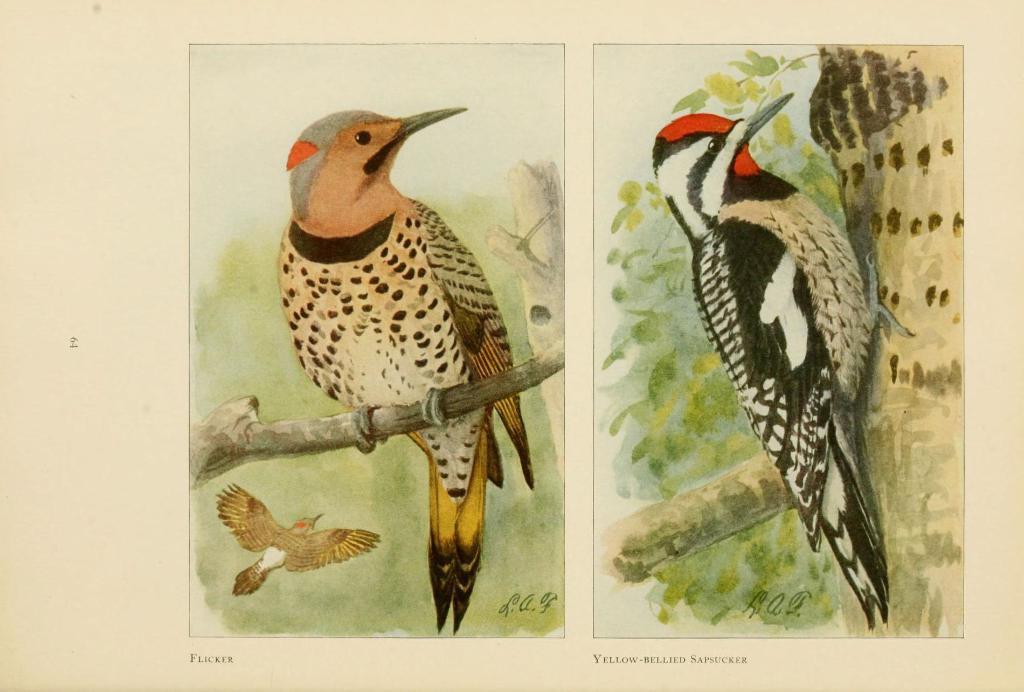In one or two sentences, can you explain what this image depicts? This image is a painting. In this we can see paintings of a bird on the tree. 